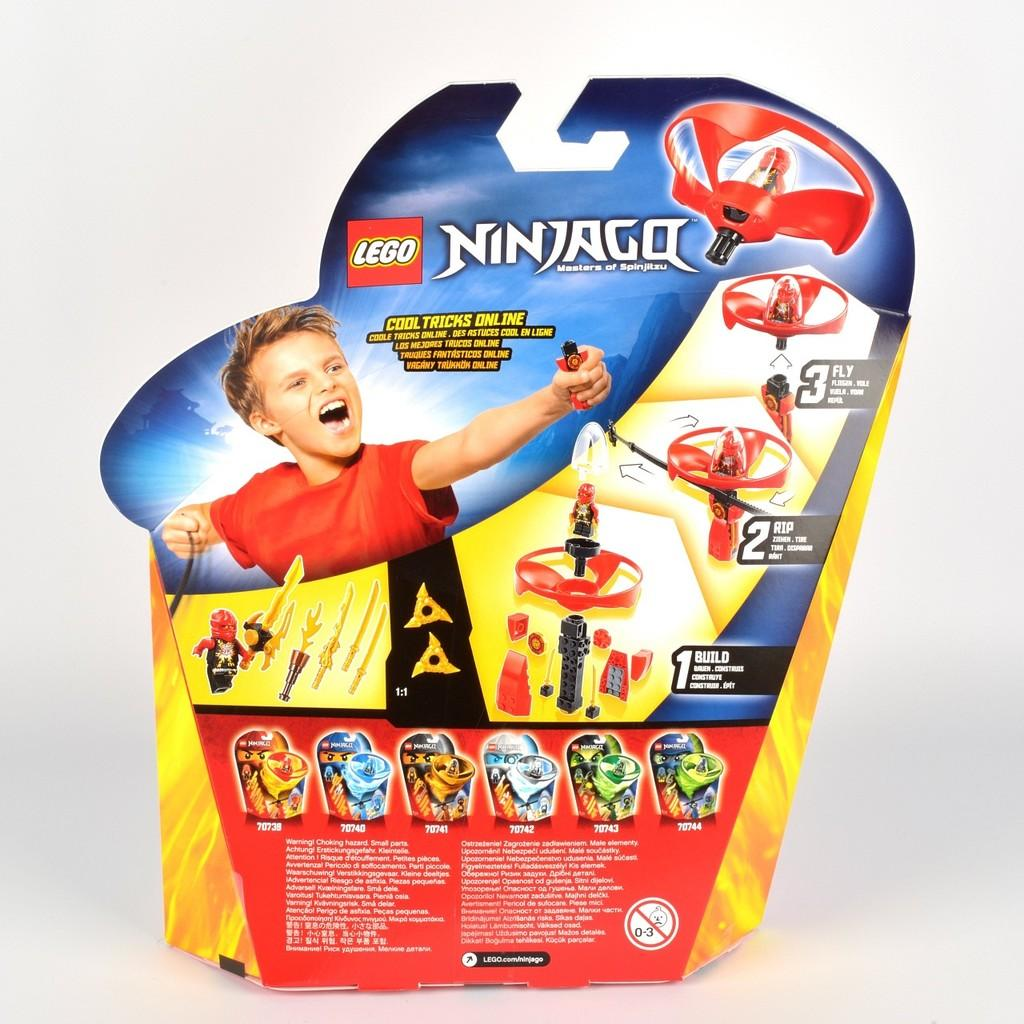What is the main object in the image? There is a Lego game box in the image. What can be seen on the Lego game box? The Lego game box has pictures of toys on it. Who is present in the image? There is a child present in the image. How many quilts are being used by the child in the image? There is no quilt present in the image, and the child is not using any quilts. 